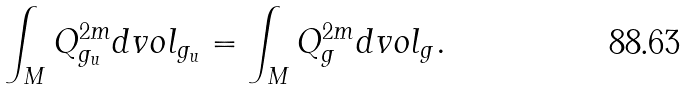<formula> <loc_0><loc_0><loc_500><loc_500>\int _ { M } Q _ { g _ { u } } ^ { 2 m } d v o l _ { g _ { u } } = \int _ { M } Q _ { g } ^ { 2 m } d v o l _ { g } .</formula> 